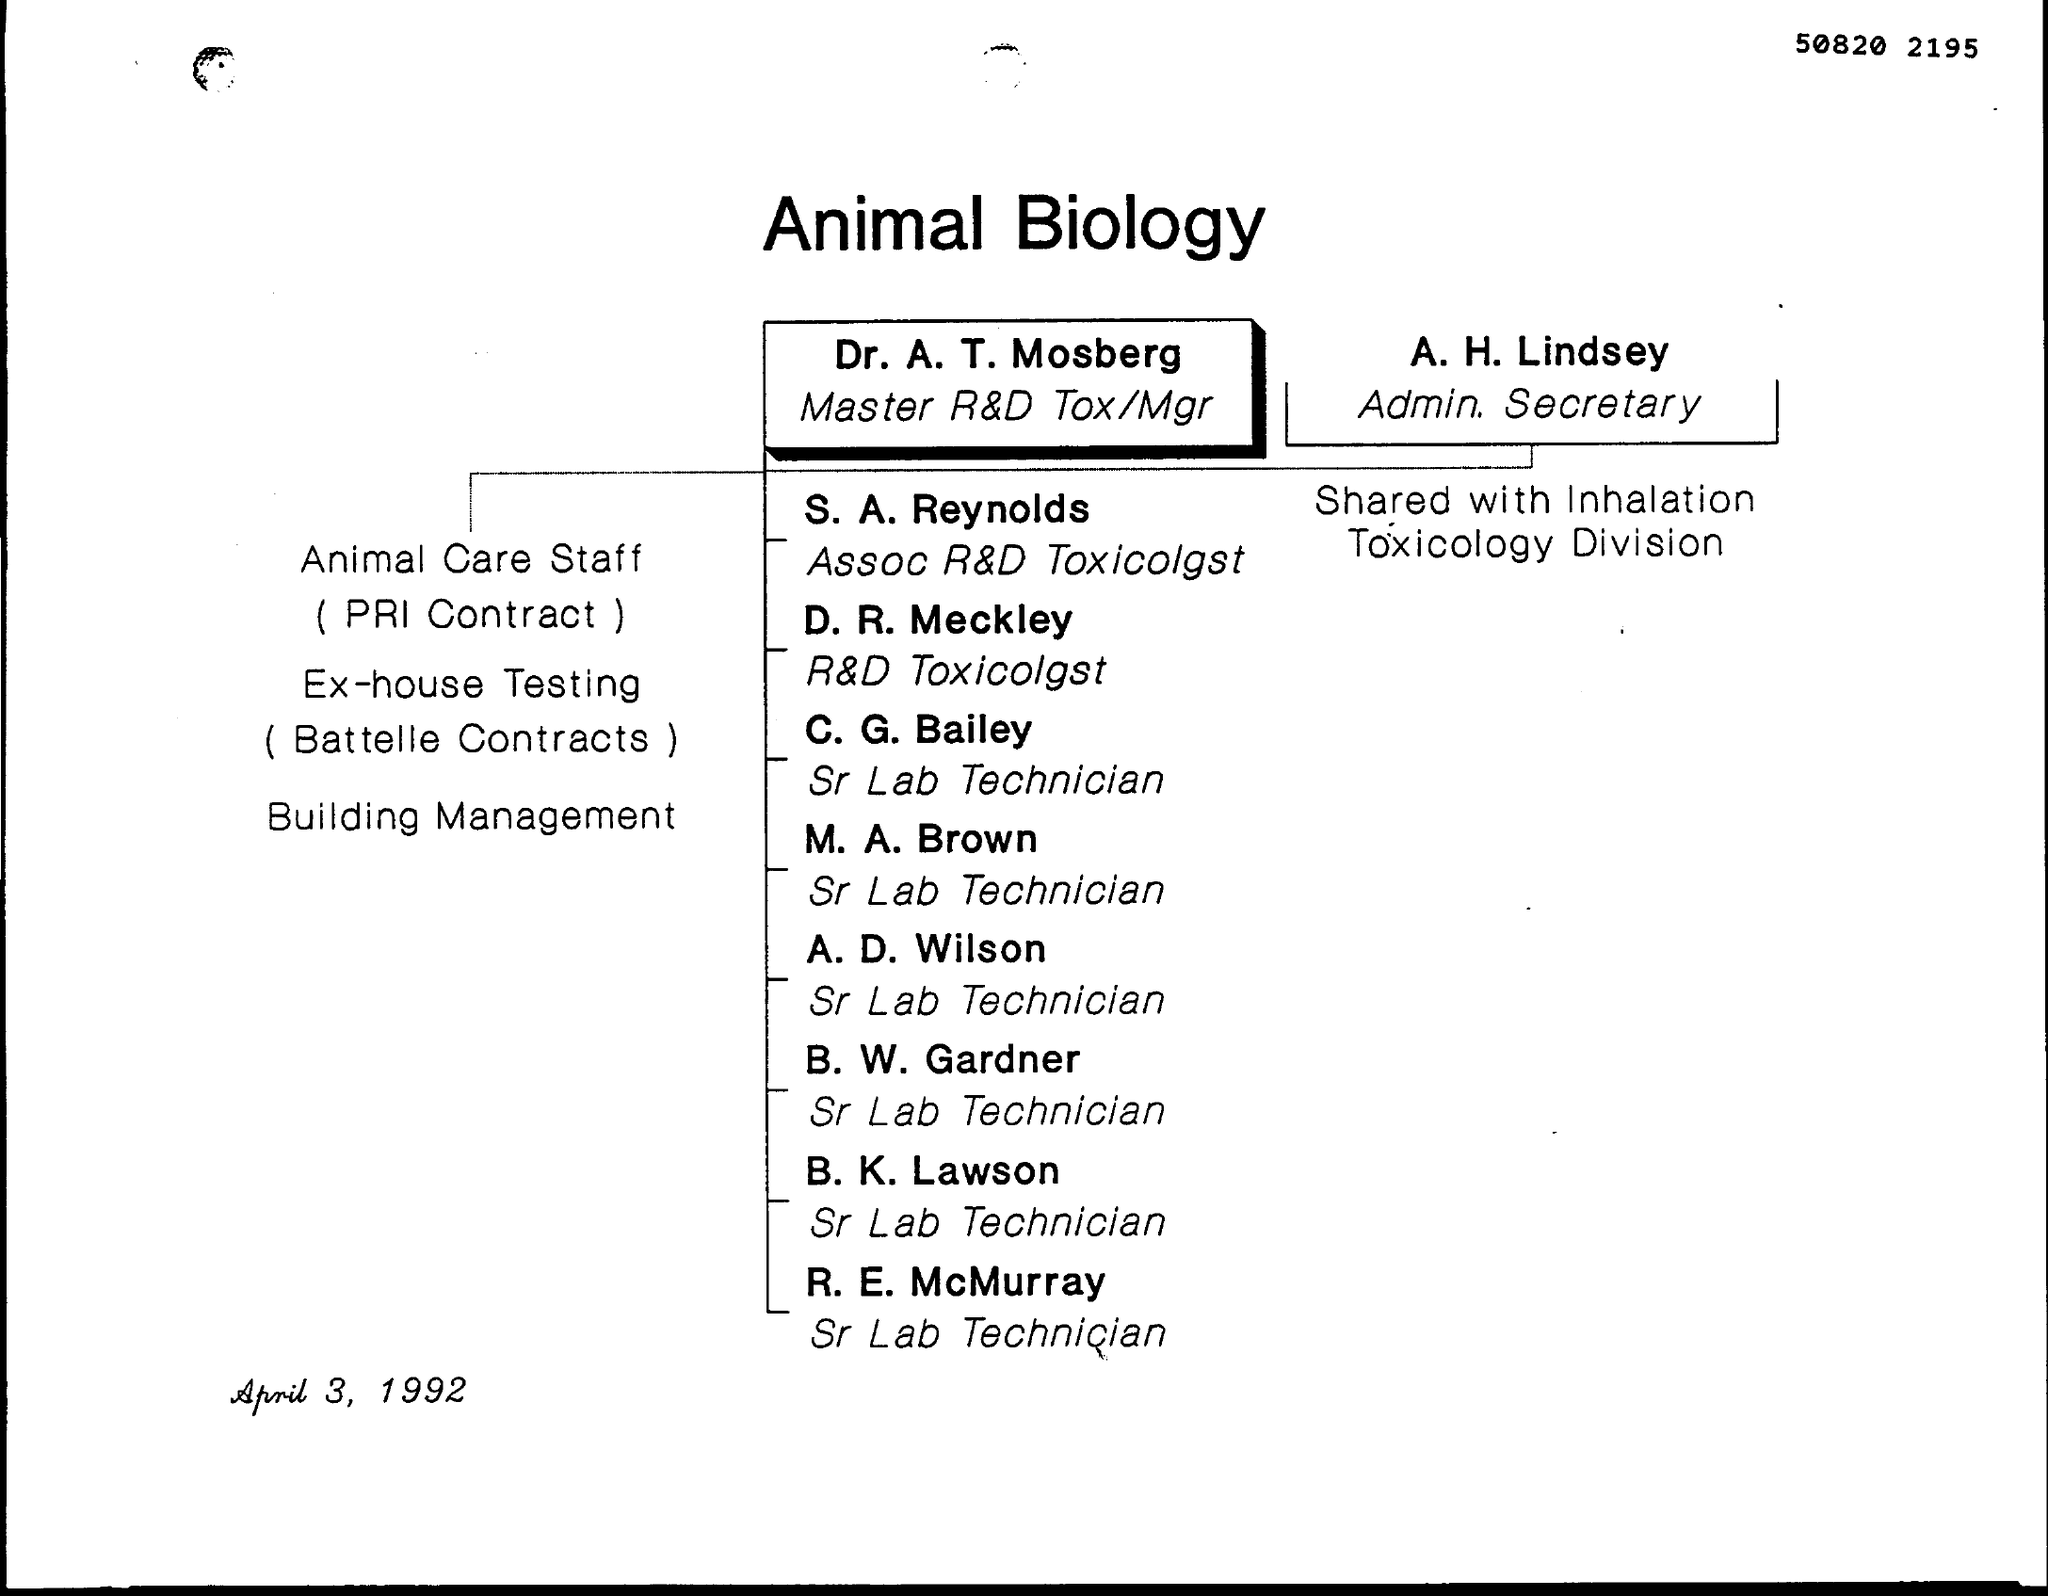What is the title of the document ?
Your answer should be very brief. Animal Biology. What is the designation of R. E. McMurray ?
Offer a very short reply. Sr Lab Technician. Animal Care Staff comes from which contractors?
Your answer should be compact. PRI Contract. 